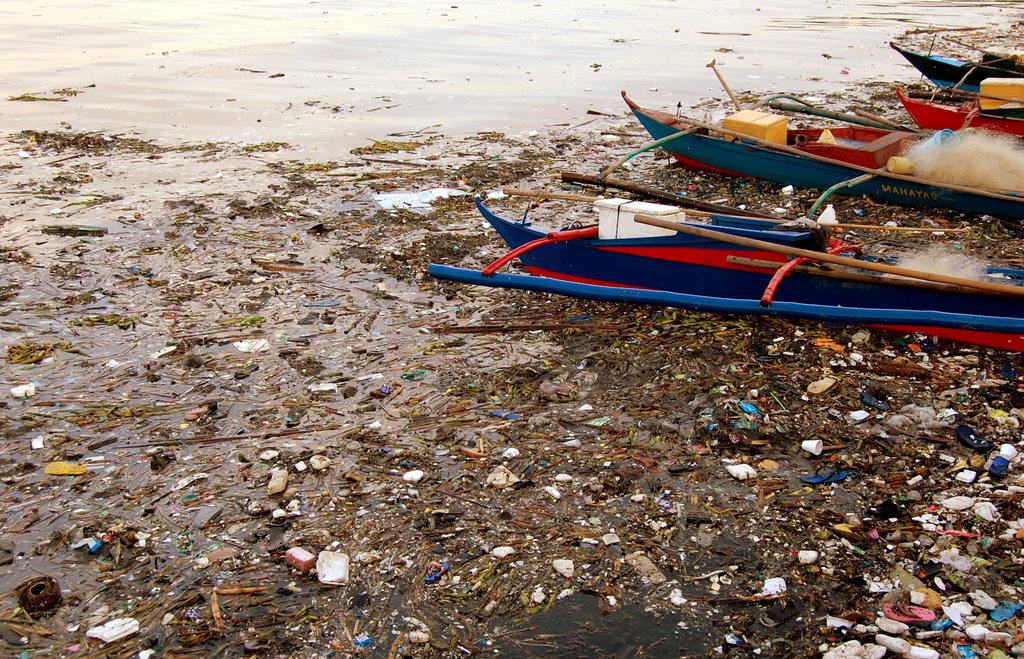What is the main feature of the image? There is a water body in the image. What can be seen in the foreground of the water? There is waste material in the foreground of the water. Where are the boats located in the image? The boats are on the right side of the image. How many beds can be seen in the image? There are no beds present in the image. What type of stamp is visible on the water in the image? There is no stamp visible on the water in the image. 